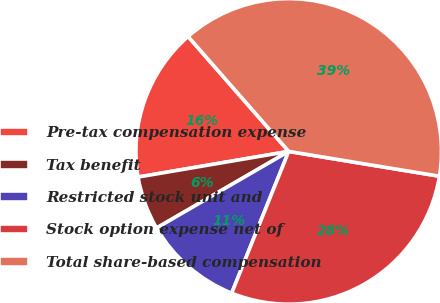<chart> <loc_0><loc_0><loc_500><loc_500><pie_chart><fcel>Pre-tax compensation expense<fcel>Tax benefit<fcel>Restricted stock unit and<fcel>Stock option expense net of<fcel>Total share-based compensation<nl><fcel>16.24%<fcel>5.68%<fcel>10.55%<fcel>28.49%<fcel>39.04%<nl></chart> 